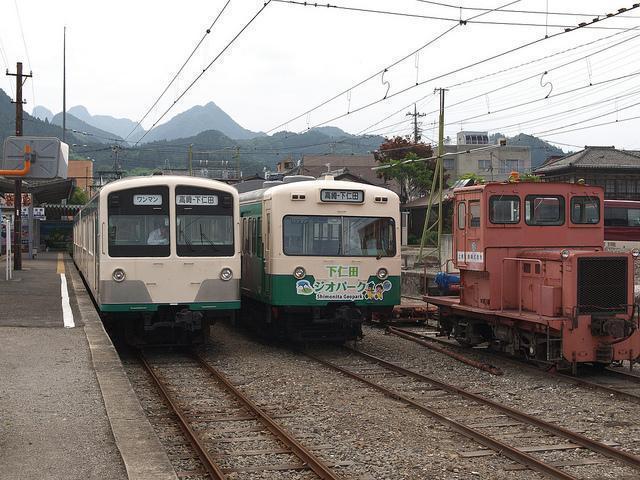What language is mainly spoken here?
Indicate the correct response by choosing from the four available options to answer the question.
Options: Japanese, taiwanese, mandarin, korean. Japanese. 